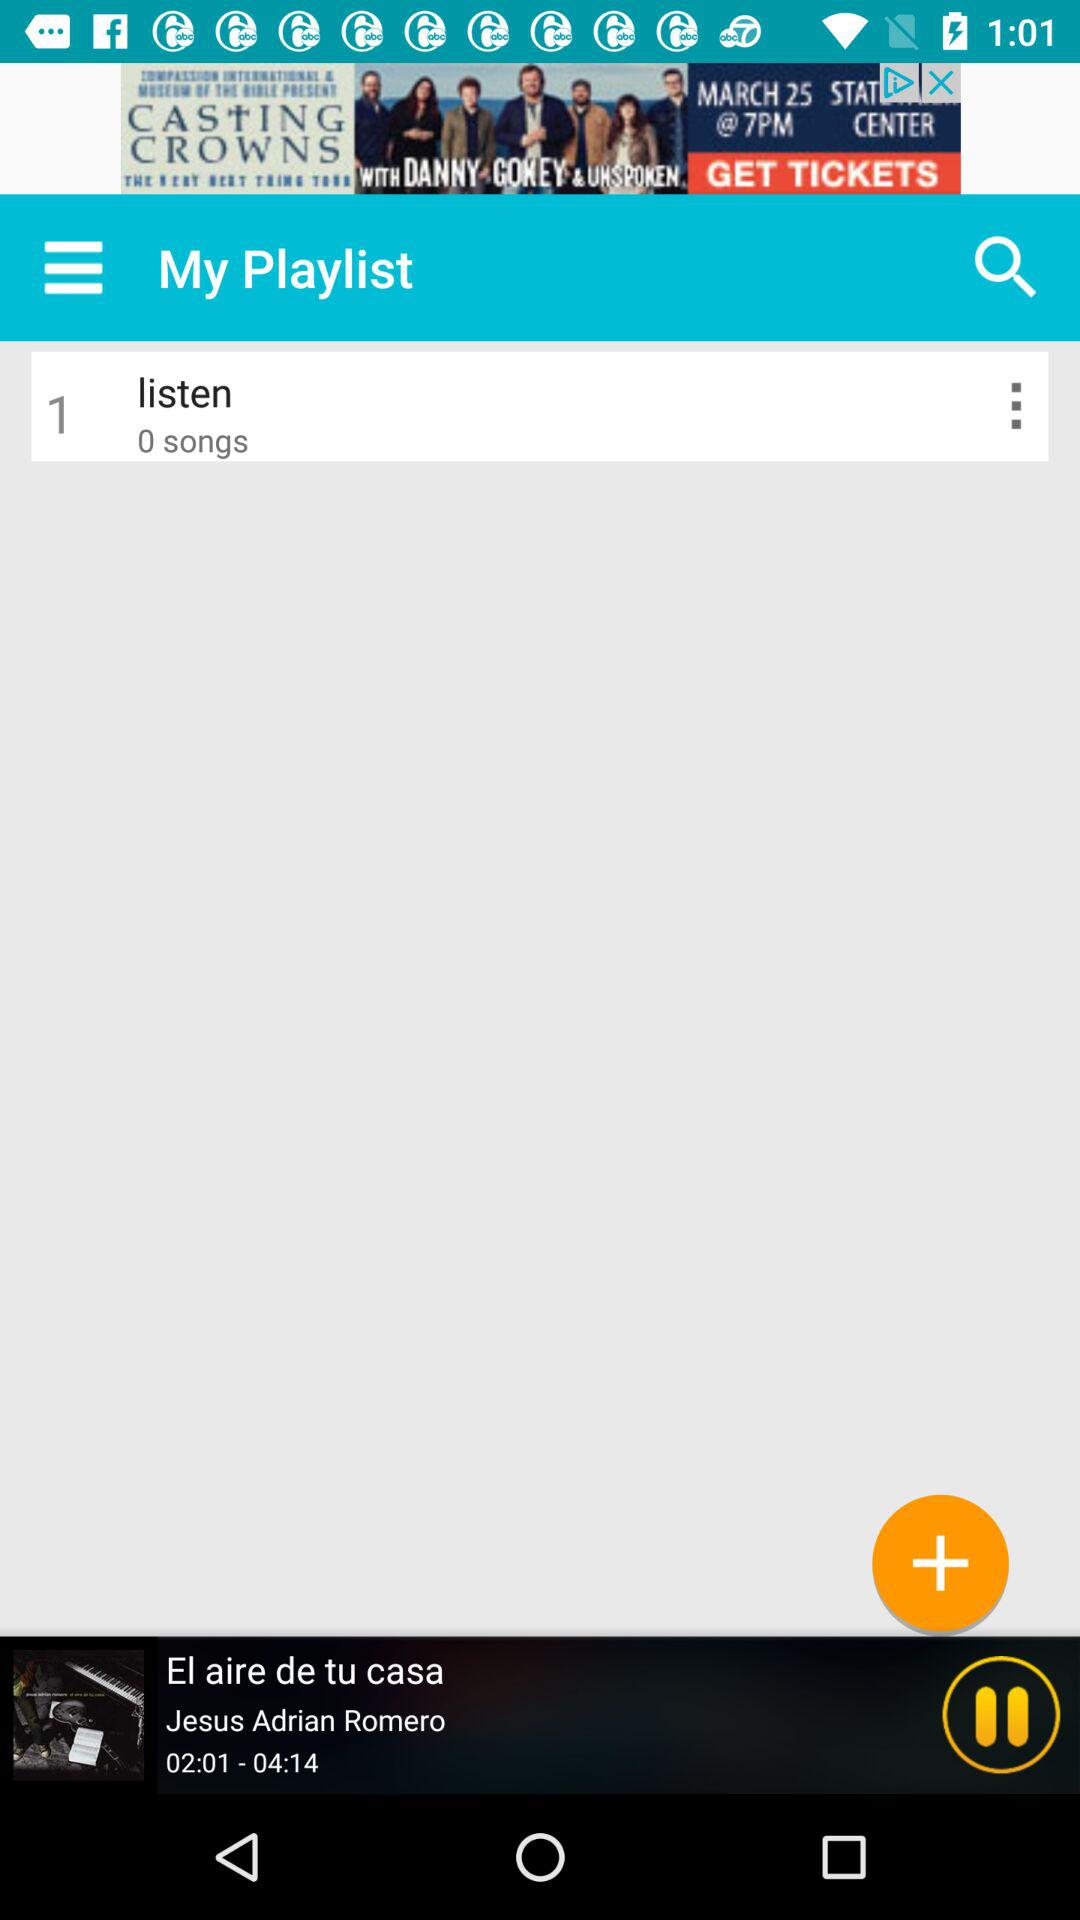What song is playing? The song "El aire de tu casa" is playing. 